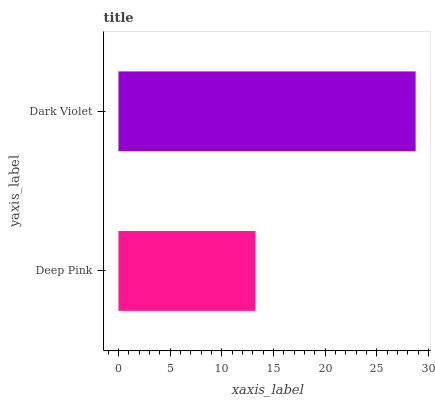Is Deep Pink the minimum?
Answer yes or no. Yes. Is Dark Violet the maximum?
Answer yes or no. Yes. Is Dark Violet the minimum?
Answer yes or no. No. Is Dark Violet greater than Deep Pink?
Answer yes or no. Yes. Is Deep Pink less than Dark Violet?
Answer yes or no. Yes. Is Deep Pink greater than Dark Violet?
Answer yes or no. No. Is Dark Violet less than Deep Pink?
Answer yes or no. No. Is Dark Violet the high median?
Answer yes or no. Yes. Is Deep Pink the low median?
Answer yes or no. Yes. Is Deep Pink the high median?
Answer yes or no. No. Is Dark Violet the low median?
Answer yes or no. No. 